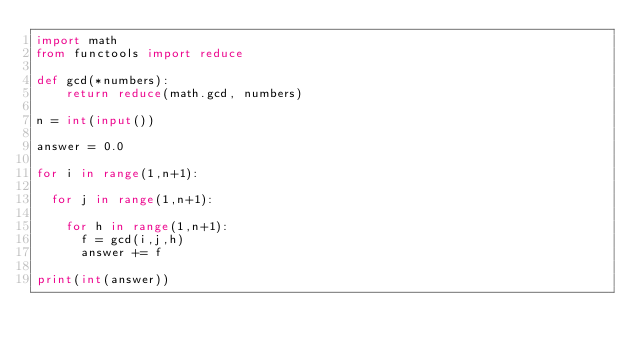<code> <loc_0><loc_0><loc_500><loc_500><_Python_>import math
from functools import reduce

def gcd(*numbers):
    return reduce(math.gcd, numbers)

n = int(input())

answer = 0.0

for i in range(1,n+1):
  
  for j in range(1,n+1):
    
    for h in range(1,n+1):
      f = gcd(i,j,h)
      answer += f
      
print(int(answer))</code> 